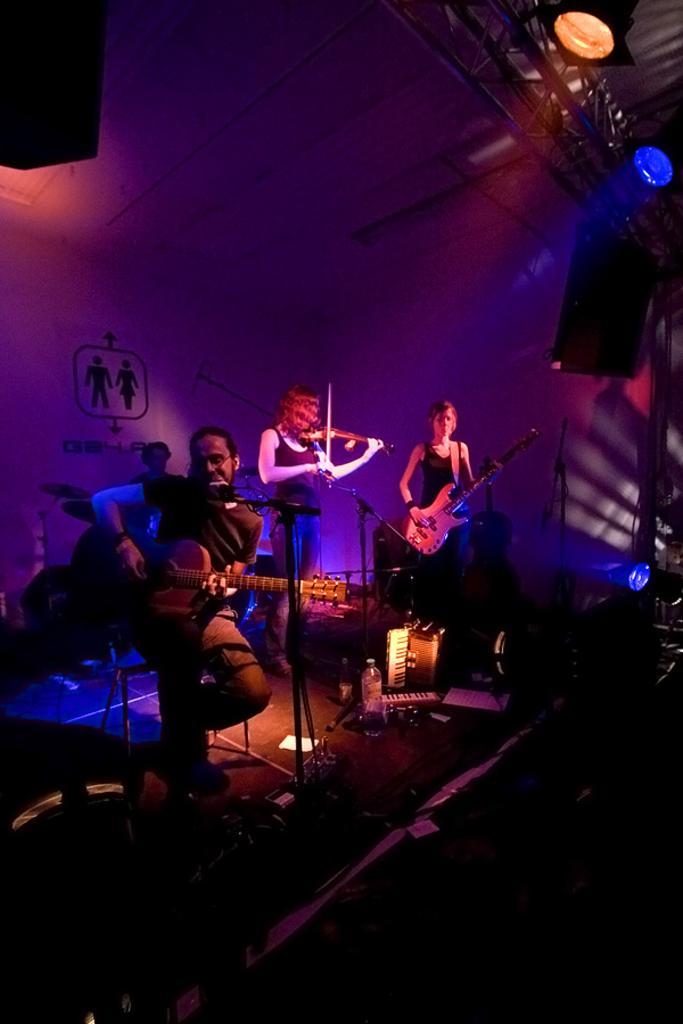Please provide a concise description of this image. The picture is taken on the stage where people are performing, coming to the left corner of the picture one person is sitting and playing a guitar in front of the microphone and to the right corner of the picture one woman is standing and playing the guitar and behind her there is a one woman playing the violin and behind her there is one person is sitting and playing the drums and behind them there is a pink poster present and in front of them there are speakers and on the floor there is one bottle and keyboard. 